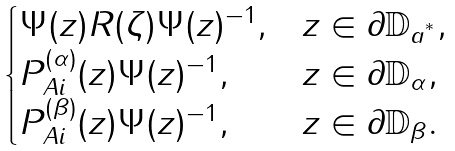<formula> <loc_0><loc_0><loc_500><loc_500>\begin{cases} { \Psi } ( z ) { R } ( \zeta ) { \Psi } ( z ) ^ { - 1 } , & z \in \partial \mathbb { D } _ { a ^ { ^ { * } } } , \\ { P } _ { A i } ^ { ( \alpha ) } ( z ) { \Psi } ( z ) ^ { - 1 } , & z \in \partial \mathbb { D } _ { \alpha } , \\ { P } _ { A i } ^ { ( \beta ) } ( z ) { \Psi } ( z ) ^ { - 1 } , & z \in \partial \mathbb { D } _ { \beta } . \end{cases}</formula> 